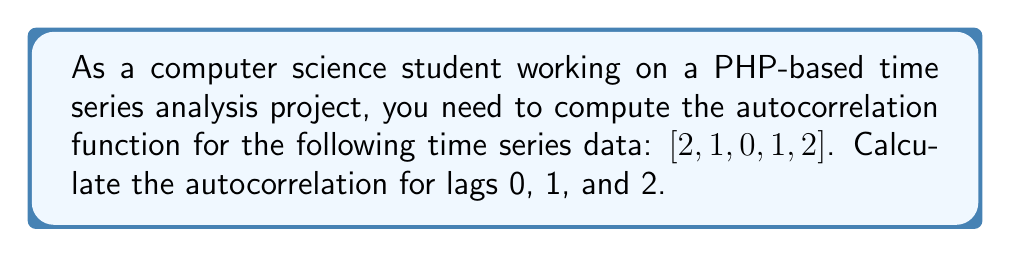What is the answer to this math problem? To compute the autocorrelation function for the given time series, we'll follow these steps:

1. Calculate the mean of the time series:
   $$\mu = \frac{2 + 1 + 0 + 1 + 2}{5} = 1.2$$

2. Calculate the variance of the time series:
   $$\sigma^2 = \frac{1}{5}\sum_{t=1}^{5} (x_t - \mu)^2 = \frac{(2-1.2)^2 + (1-1.2)^2 + (0-1.2)^2 + (1-1.2)^2 + (2-1.2)^2}{5} = 0.56$$

3. For each lag k, compute the autocorrelation using the formula:
   $$r_k = \frac{\sum_{t=1}^{N-k} (x_t - \mu)(x_{t+k} - \mu)}{\sum_{t=1}^{N} (x_t - \mu)^2}$$

   Where N is the length of the time series (5 in this case).

4. Compute autocorrelation for lag 0:
   $$r_0 = \frac{(2-1.2)^2 + (1-1.2)^2 + (0-1.2)^2 + (1-1.2)^2 + (2-1.2)^2}{(2-1.2)^2 + (1-1.2)^2 + (0-1.2)^2 + (1-1.2)^2 + (2-1.2)^2} = 1$$

5. Compute autocorrelation for lag 1:
   $$r_1 = \frac{(2-1.2)(1-1.2) + (1-1.2)(0-1.2) + (0-1.2)(1-1.2) + (1-1.2)(2-1.2)}{(2-1.2)^2 + (1-1.2)^2 + (0-1.2)^2 + (1-1.2)^2 + (2-1.2)^2} = 0$$

6. Compute autocorrelation for lag 2:
   $$r_2 = \frac{(2-1.2)(0-1.2) + (1-1.2)(1-1.2) + (0-1.2)(2-1.2)}{(2-1.2)^2 + (1-1.2)^2 + (0-1.2)^2 + (1-1.2)^2 + (2-1.2)^2} = -0.5$$
Answer: $r_0 = 1$, $r_1 = 0$, $r_2 = -0.5$ 